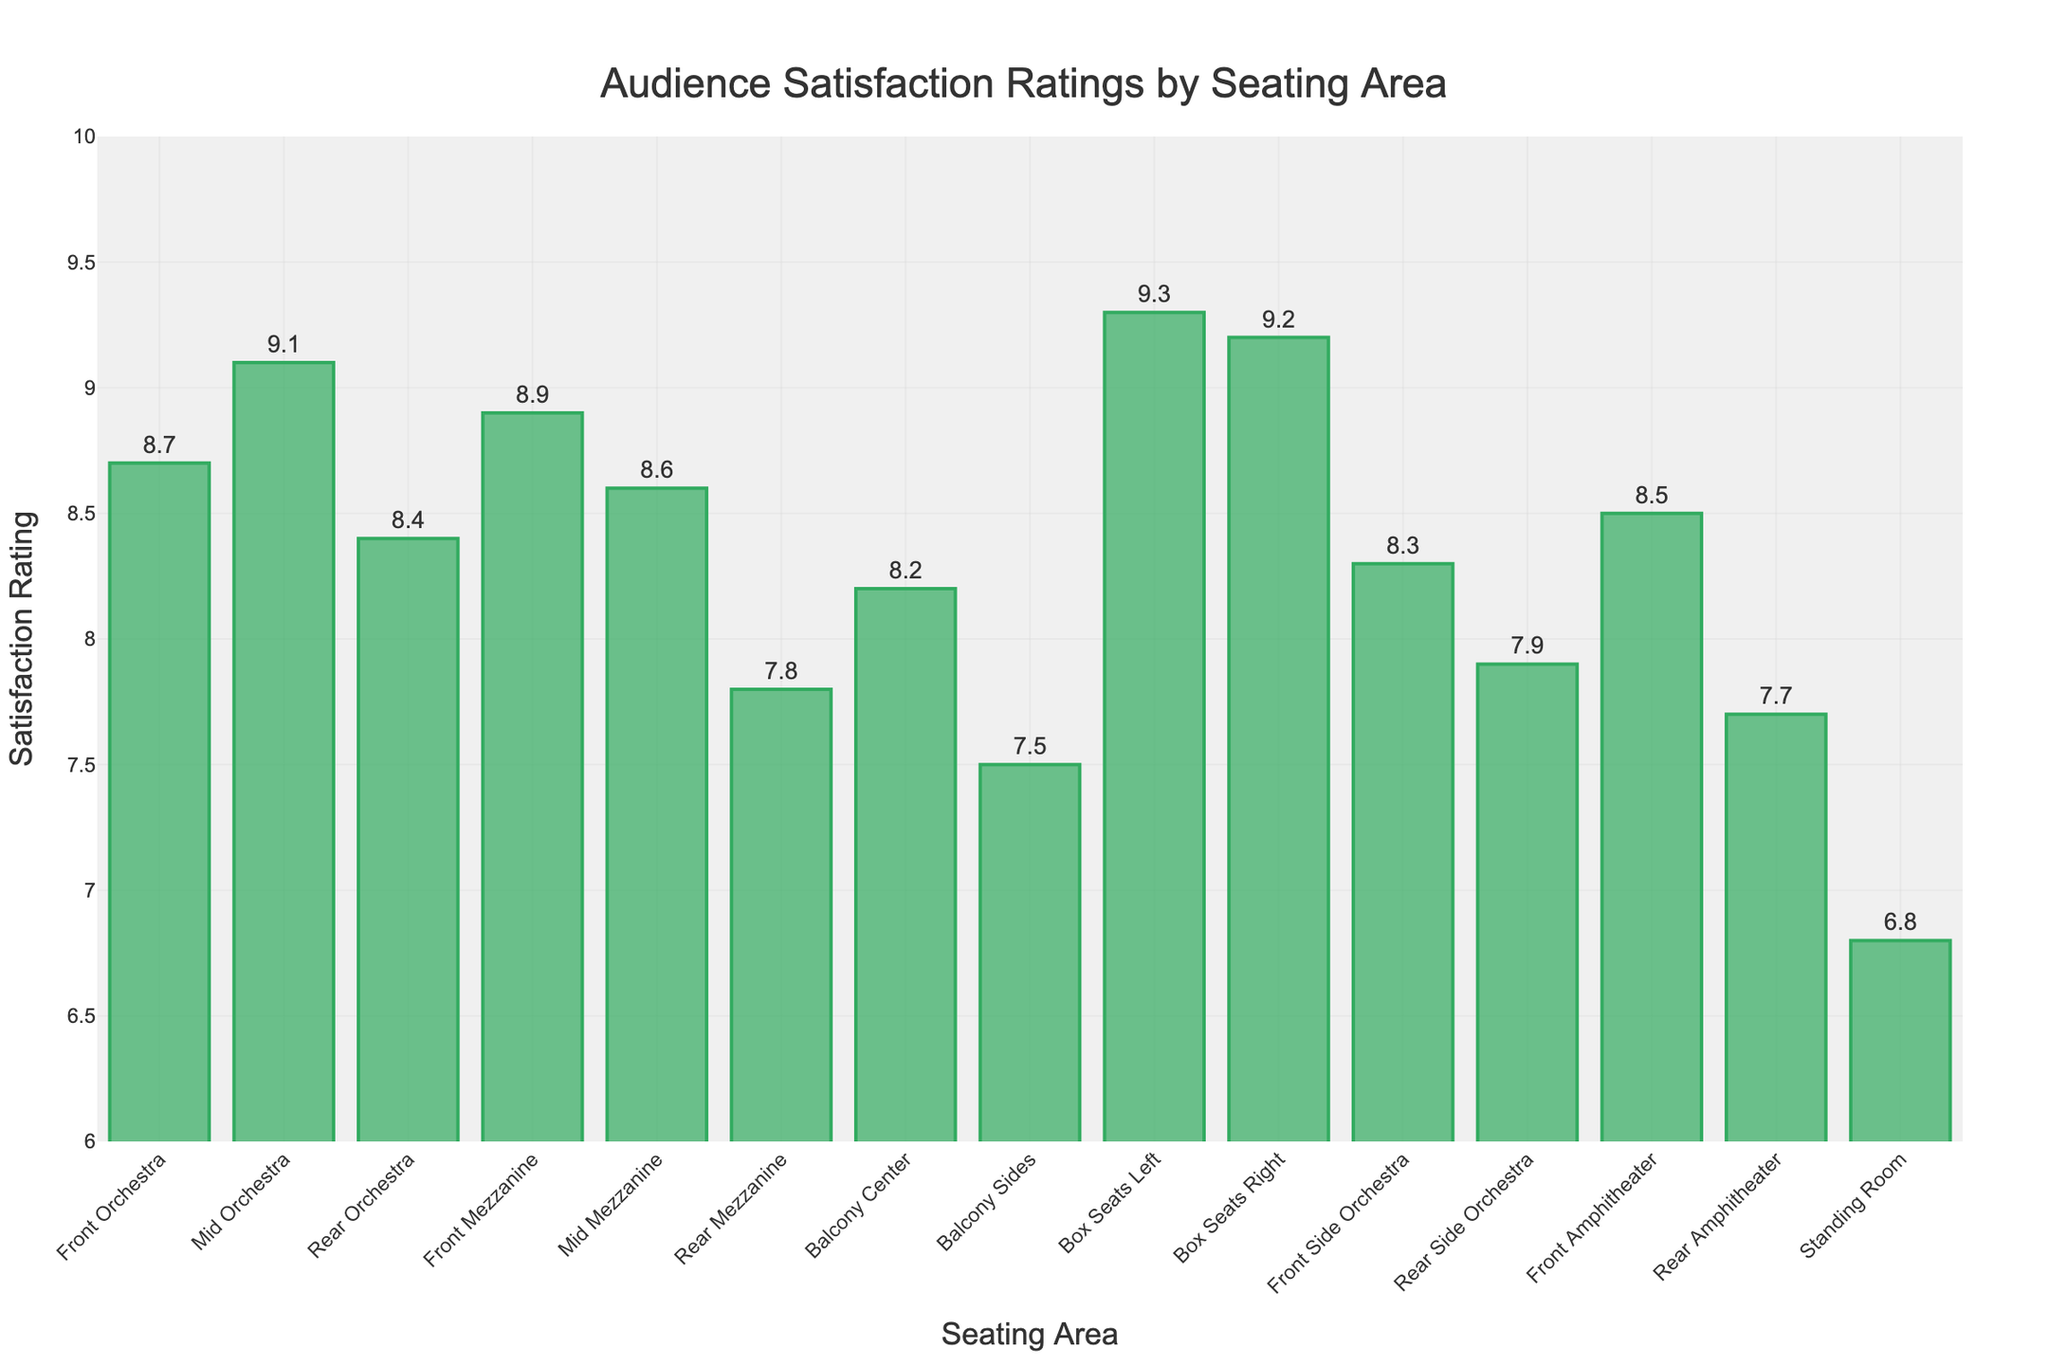What is the seating area with the highest audience satisfaction rating? The bar for "Box Seats Left" is the tallest and has a value of 9.3.
Answer: Box Seats Left How much higher is the rating of the Box Seats Right compared to the Balcony Sides? The rating for Box Seats Right is 9.2, and for Balcony Sides, it is 7.5. Subtracting 7.5 from 9.2 gives 1.7.
Answer: 1.7 Which seating area has the lowest audience satisfaction rating? The bar for "Standing Room" is the shortest and has a value of 6.8.
Answer: Standing Room Is the satisfaction rating of Mid Orchestra greater than that of Front Mezzanine? The bar for Mid Orchestra is at 9.1, and the bar for Front Mezzanine is at 8.9. Since 9.1 is greater than 8.9, the answer is yes.
Answer: Yes What is the average satisfaction rating for the Mid Mezzanine and Rear Mezzanine areas? The rating for Mid Mezzanine is 8.6, and for Rear Mezzanine, it is 7.8. The average is (8.6 + 7.8) / 2 = 8.2.
Answer: 8.2 Which has a higher satisfaction rating, the Rear Orchestra or the Front Side Orchestra? The rating for Rear Orchestra is 8.4, and for Front Side Orchestra, it is 8.3. Since 8.4 is greater than 8.3, Rear Orchestra has a higher rating.
Answer: Rear Orchestra Are both Box Seats Left and Box Seats Right ratings above 9.0? The ratings for Box Seats Left and Box Seats Right are 9.3 and 9.2, respectively, both of which are above 9.0.
Answer: Yes What is the difference between the highest and lowest satisfaction ratings? The highest rating is 9.3 (Box Seats Left), and the lowest is 6.8 (Standing Room). The difference is 9.3 - 6.8 = 2.5.
Answer: 2.5 Calculate the difference in satisfaction rating between Front Orchestra and Rear Amphitheater. The rating for Front Orchestra is 8.7, and for Rear Amphitheater, it is 7.7. The difference is 8.7 - 7.7 = 1.0.
Answer: 1.0 Which seating area has a higher satisfaction rating, the Front Amphitheater or the Mid Mezzanine? The rating for Front Amphitheater is 8.5, and for Mid Mezzanine, it is 8.6. Since 8.6 is greater than 8.5, Mid Mezzanine has a higher rating.
Answer: Mid Mezzanine 